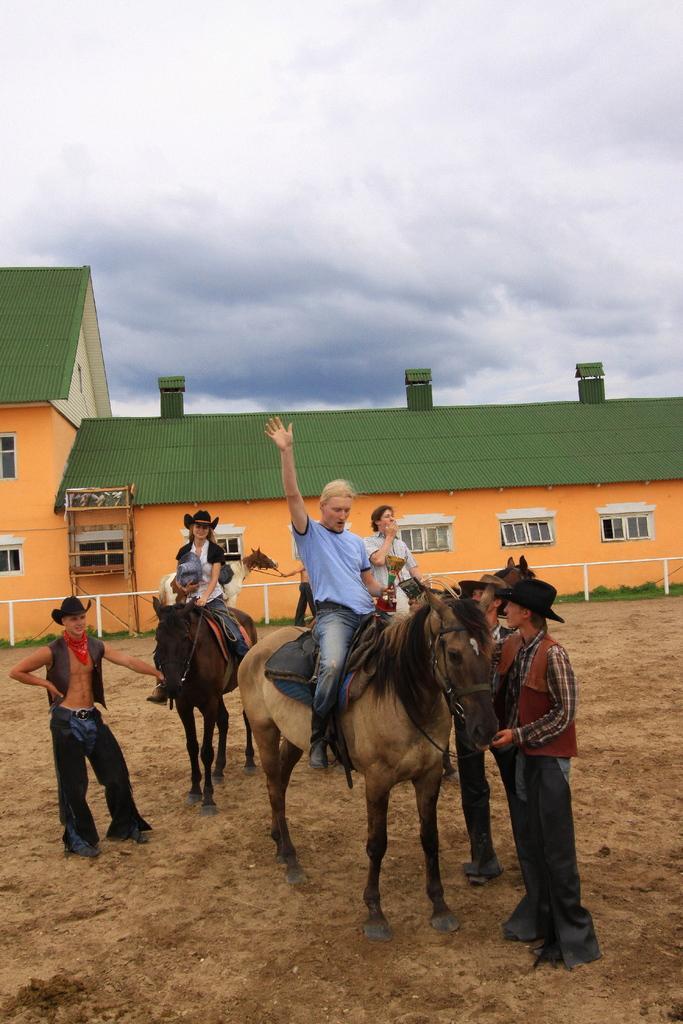Can you describe this image briefly? This is the picture of a building. In this image there are three persons sitting on the three horses and there are three persons standing. At the back there is a building and there is a railing. At the top there are clouds. At the bottom there is grass and mud. 